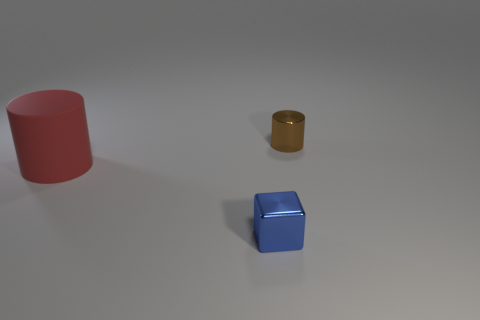Add 2 tiny yellow spheres. How many objects exist? 5 Subtract all blocks. How many objects are left? 2 Add 3 large rubber cylinders. How many large rubber cylinders are left? 4 Add 2 small cylinders. How many small cylinders exist? 3 Subtract 0 cyan balls. How many objects are left? 3 Subtract all big yellow balls. Subtract all small brown metallic things. How many objects are left? 2 